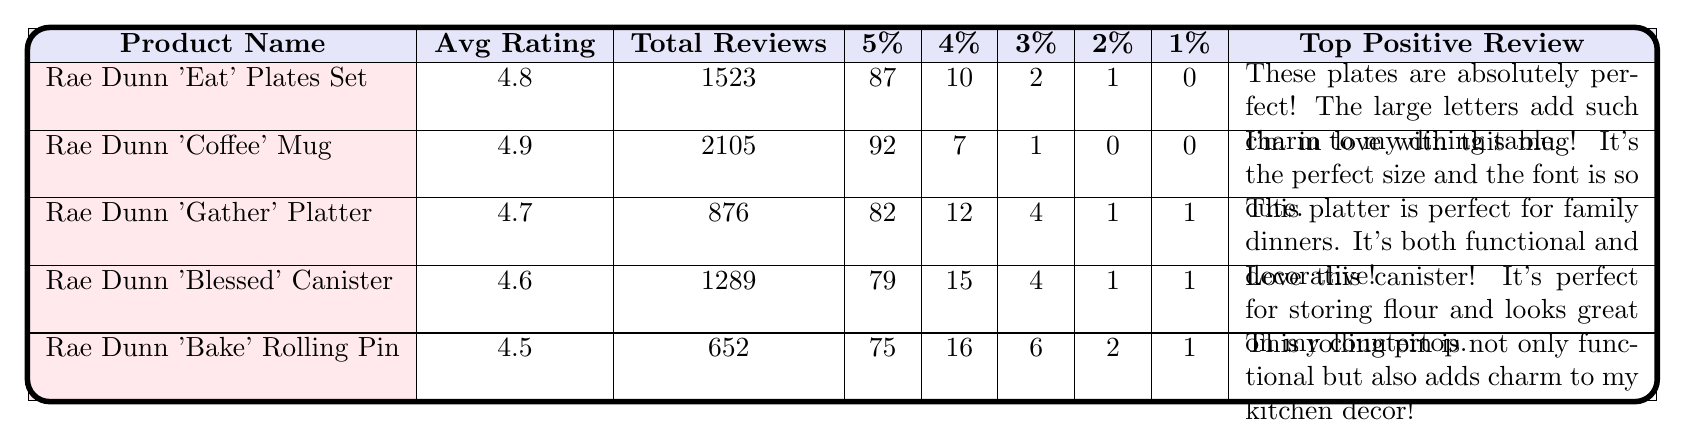What is the average rating of the Rae Dunn 'Coffee' Mug? The average rating is listed directly in the table next to the product name. For the 'Coffee' Mug, the average rating is 4.9.
Answer: 4.9 How many total reviews did the Rae Dunn 'Blessed' Ceramic Canister receive? The table provides the total reviews for each product next to the product name. The 'Blessed' Canister received a total of 1289 reviews.
Answer: 1289 What percentage of reviews for the Rae Dunn 'Gather' Serving Platter were 5 stars? The table shows the percentage of 5-star reviews for the 'Gather' Platter as 82%.
Answer: 82% Which product has the highest average rating? To find this, compare the average ratings of all listed products. The 'Coffee' Mug has the highest average rating at 4.9.
Answer: Rae Dunn 'Coffee' Mug Which product had the most total reviews? By looking at the total reviews column in the table, the product with the most reviews is the 'Coffee' Mug with 2105 reviews.
Answer: Rae Dunn 'Coffee' Mug What is the average rating of products that have more than 1000 reviews? The ratings for products with more than 1000 reviews are 4.9 (Coffee Mug), 4.8 (Wash Soap Dispenser), 4.7 (Gather Platter), and 4.6 (Blessed Canister). The total is 4.9 + 4.8 + 4.7 + 4.6 = 19. The average is 19/4 = 4.75.
Answer: 4.75 How many products received at least an average rating of 4.6? Check the average ratings in the table and count the products with ratings of 4.6 or higher. The products are the 'Coffee' Mug, 'Eat' Plates Set, 'Gather' Platter, 'Blessed' Canister, 'Bloom' Vase, 'Wash' Soap Dispenser, 'Grateful' Pillow, 'Sip' Glasses Set, 'Enjoy' Bowl, 'Bless This Home' Wall Decor, 'Measure' Cups Set, 'Woof' Dog Bowl, 'Nap Queen' Blanket, 'Rise & Shine' Egg Holder, 'Smile' Toothbrush Holder, 'Yum' Cake Stand, and 'Honey' Pot. That's a total of 16 products.
Answer: 16 Did any product receive 100% ratings for 5-star reviews? None of the products in the table have a 100% rating for 5-star reviews as the maximum percentage shown is 94%, which belongs to the 'Rise & Shine' Egg Holder.
Answer: No 